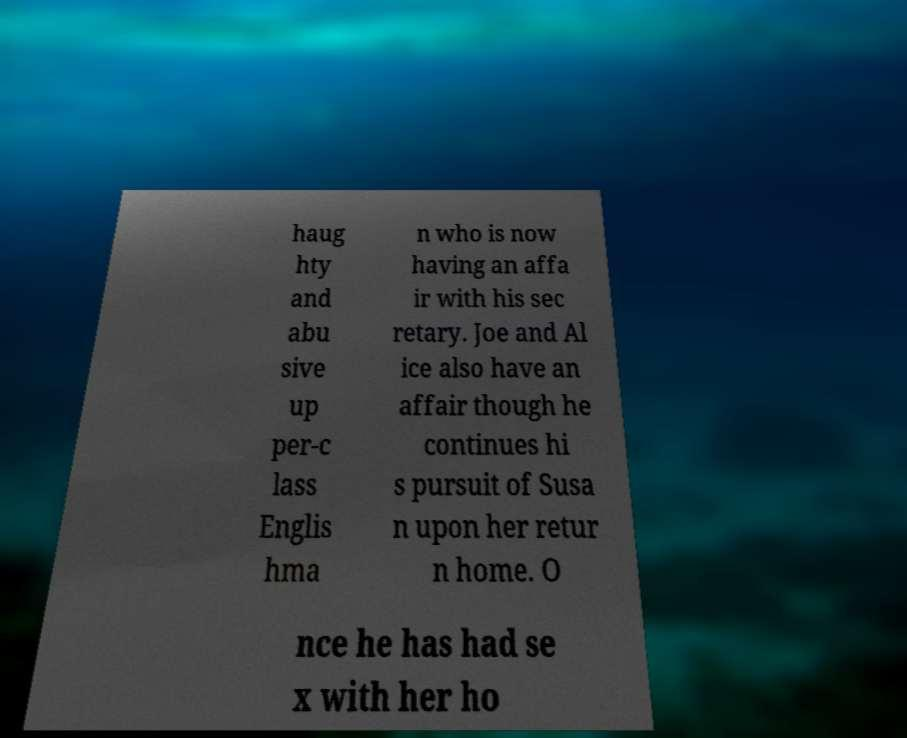There's text embedded in this image that I need extracted. Can you transcribe it verbatim? haug hty and abu sive up per-c lass Englis hma n who is now having an affa ir with his sec retary. Joe and Al ice also have an affair though he continues hi s pursuit of Susa n upon her retur n home. O nce he has had se x with her ho 